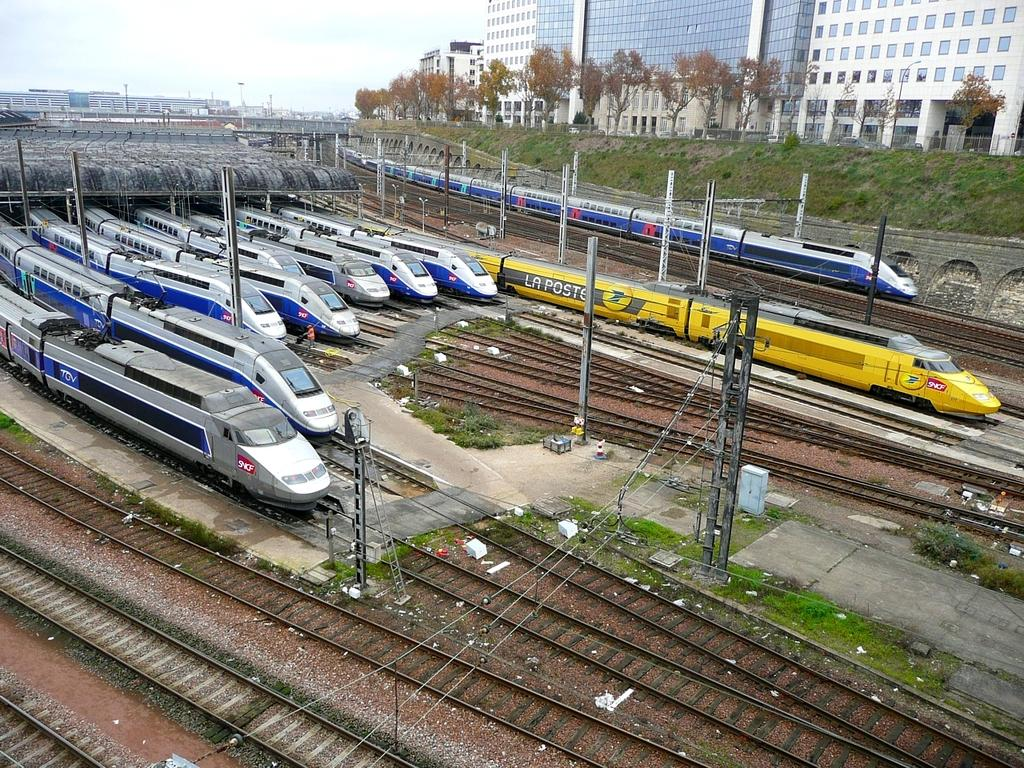What type of vehicles are present in the image? There are trains in the image. Where are the trains located? The trains are standing on railway tracks. What type of vegetation can be seen in the image? There are trees visible in the image. What can be seen in the distance in the image? There are buildings in the background of the image. What type of curtain can be seen hanging in the train in the image? There is no curtain visible in the image; it is focused on the trains standing on railway tracks. 